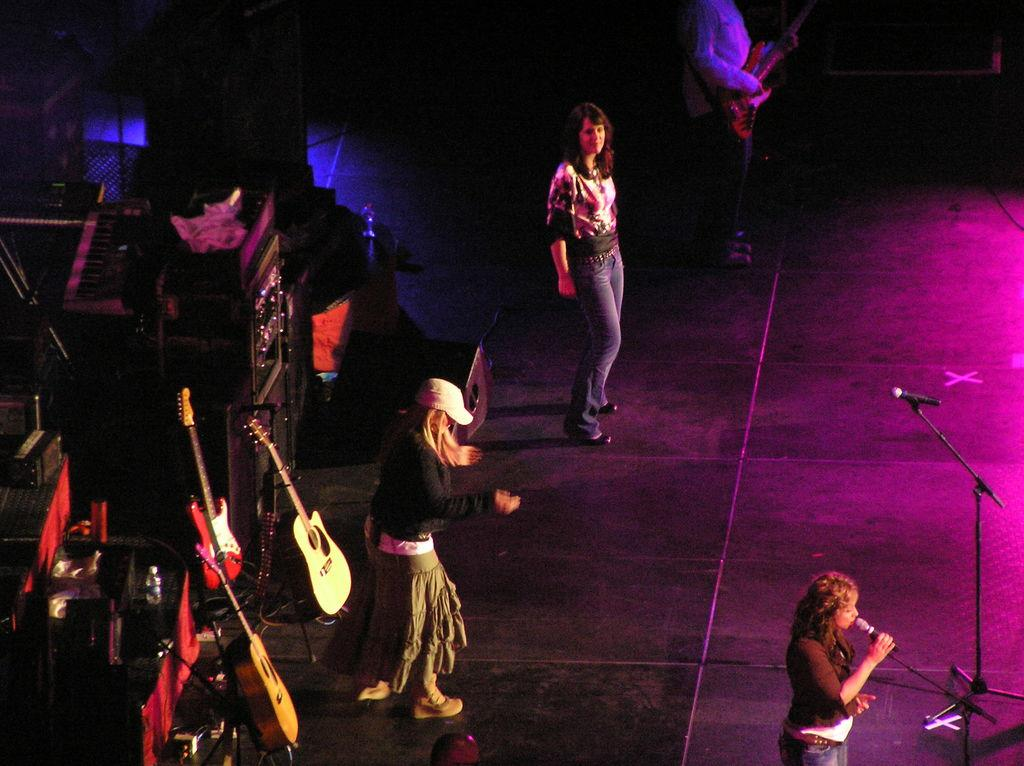What is happening in the image? There is a group of people performing on stage. Can you describe the performers in the image? Three of the performers are women, and one is a man. What type of pancake is being flipped by the performers in the image? There is no pancake present in the image; it features a group of people performing on stage. How does the anger of the performers affect their performance in the image? There is no indication of anger in the image; the performers are simply performing on stage. 